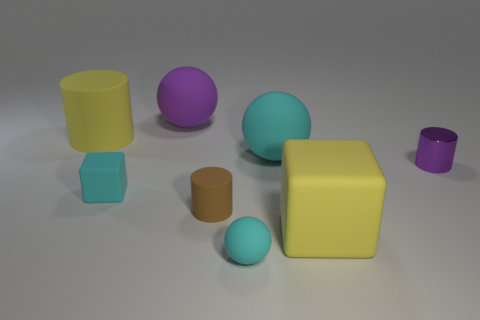What shape is the small brown thing that is the same material as the large cyan sphere?
Provide a short and direct response. Cylinder. There is a matte cylinder in front of the large matte ball in front of the large yellow matte object that is left of the large yellow matte block; what size is it?
Ensure brevity in your answer.  Small. Are there more small blue rubber cubes than tiny purple shiny things?
Your answer should be compact. No. Does the rubber ball that is on the right side of the tiny rubber ball have the same color as the sphere that is in front of the shiny thing?
Keep it short and to the point. Yes. Are the yellow cylinder that is behind the purple shiny thing and the ball to the right of the small cyan matte sphere made of the same material?
Your answer should be compact. Yes. How many cyan blocks are the same size as the purple cylinder?
Offer a terse response. 1. Is the number of yellow metallic cylinders less than the number of small cyan things?
Keep it short and to the point. Yes. What is the shape of the yellow rubber object that is on the left side of the small cylinder that is on the left side of the small metal cylinder?
Make the answer very short. Cylinder. There is a purple thing that is the same size as the brown matte thing; what shape is it?
Offer a very short reply. Cylinder. Are there any other rubber things that have the same shape as the brown thing?
Provide a succinct answer. Yes. 